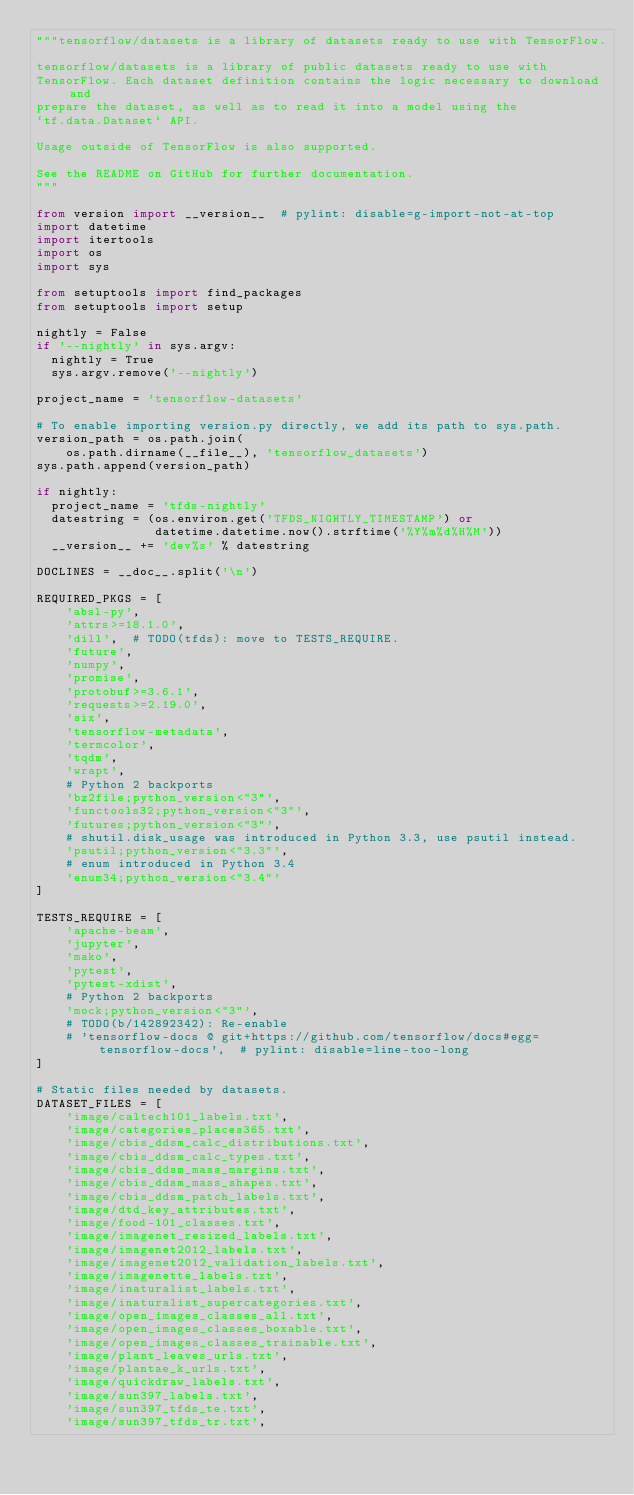Convert code to text. <code><loc_0><loc_0><loc_500><loc_500><_Python_>"""tensorflow/datasets is a library of datasets ready to use with TensorFlow.

tensorflow/datasets is a library of public datasets ready to use with
TensorFlow. Each dataset definition contains the logic necessary to download and
prepare the dataset, as well as to read it into a model using the
`tf.data.Dataset` API.

Usage outside of TensorFlow is also supported.

See the README on GitHub for further documentation.
"""

from version import __version__  # pylint: disable=g-import-not-at-top
import datetime
import itertools
import os
import sys

from setuptools import find_packages
from setuptools import setup

nightly = False
if '--nightly' in sys.argv:
  nightly = True
  sys.argv.remove('--nightly')

project_name = 'tensorflow-datasets'

# To enable importing version.py directly, we add its path to sys.path.
version_path = os.path.join(
    os.path.dirname(__file__), 'tensorflow_datasets')
sys.path.append(version_path)

if nightly:
  project_name = 'tfds-nightly'
  datestring = (os.environ.get('TFDS_NIGHTLY_TIMESTAMP') or
                datetime.datetime.now().strftime('%Y%m%d%H%M'))
  __version__ += 'dev%s' % datestring

DOCLINES = __doc__.split('\n')

REQUIRED_PKGS = [
    'absl-py',
    'attrs>=18.1.0',
    'dill',  # TODO(tfds): move to TESTS_REQUIRE.
    'future',
    'numpy',
    'promise',
    'protobuf>=3.6.1',
    'requests>=2.19.0',
    'six',
    'tensorflow-metadata',
    'termcolor',
    'tqdm',
    'wrapt',
    # Python 2 backports
    'bz2file;python_version<"3"',
    'functools32;python_version<"3"',
    'futures;python_version<"3"',
    # shutil.disk_usage was introduced in Python 3.3, use psutil instead.
    'psutil;python_version<"3.3"',
    # enum introduced in Python 3.4
    'enum34;python_version<"3.4"'
]

TESTS_REQUIRE = [
    'apache-beam',
    'jupyter',
    'mako',
    'pytest',
    'pytest-xdist',
    # Python 2 backports
    'mock;python_version<"3"',
    # TODO(b/142892342): Re-enable
    # 'tensorflow-docs @ git+https://github.com/tensorflow/docs#egg=tensorflow-docs',  # pylint: disable=line-too-long
]

# Static files needed by datasets.
DATASET_FILES = [
    'image/caltech101_labels.txt',
    'image/categories_places365.txt',
    'image/cbis_ddsm_calc_distributions.txt',
    'image/cbis_ddsm_calc_types.txt',
    'image/cbis_ddsm_mass_margins.txt',
    'image/cbis_ddsm_mass_shapes.txt',
    'image/cbis_ddsm_patch_labels.txt',
    'image/dtd_key_attributes.txt',
    'image/food-101_classes.txt',
    'image/imagenet_resized_labels.txt',
    'image/imagenet2012_labels.txt',
    'image/imagenet2012_validation_labels.txt',
    'image/imagenette_labels.txt',
    'image/inaturalist_labels.txt',
    'image/inaturalist_supercategories.txt',
    'image/open_images_classes_all.txt',
    'image/open_images_classes_boxable.txt',
    'image/open_images_classes_trainable.txt',
    'image/plant_leaves_urls.txt',
    'image/plantae_k_urls.txt',
    'image/quickdraw_labels.txt',
    'image/sun397_labels.txt',
    'image/sun397_tfds_te.txt',
    'image/sun397_tfds_tr.txt',</code> 